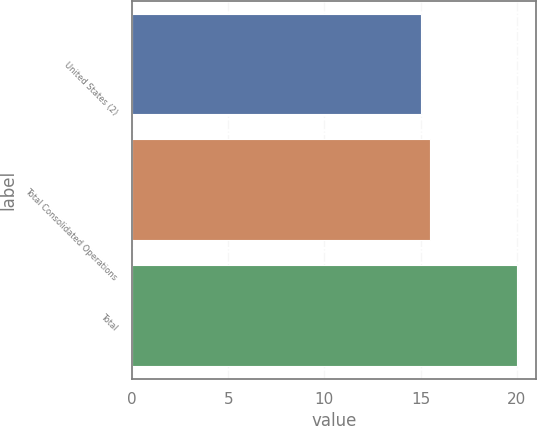Convert chart to OTSL. <chart><loc_0><loc_0><loc_500><loc_500><bar_chart><fcel>United States (2)<fcel>Total Consolidated Operations<fcel>Total<nl><fcel>15<fcel>15.5<fcel>20<nl></chart> 